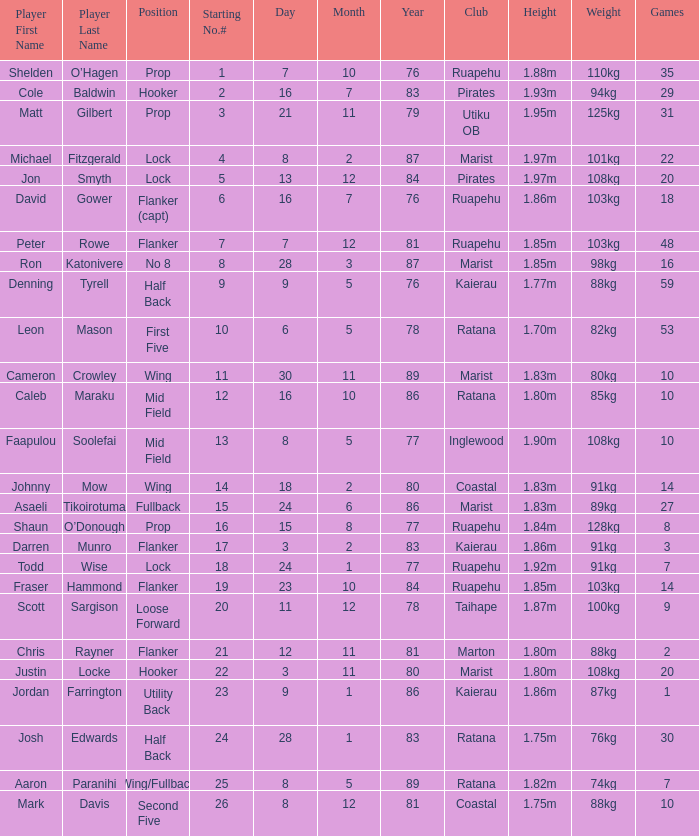What is the birthday for the player in the inglewood club? 80577.0. 